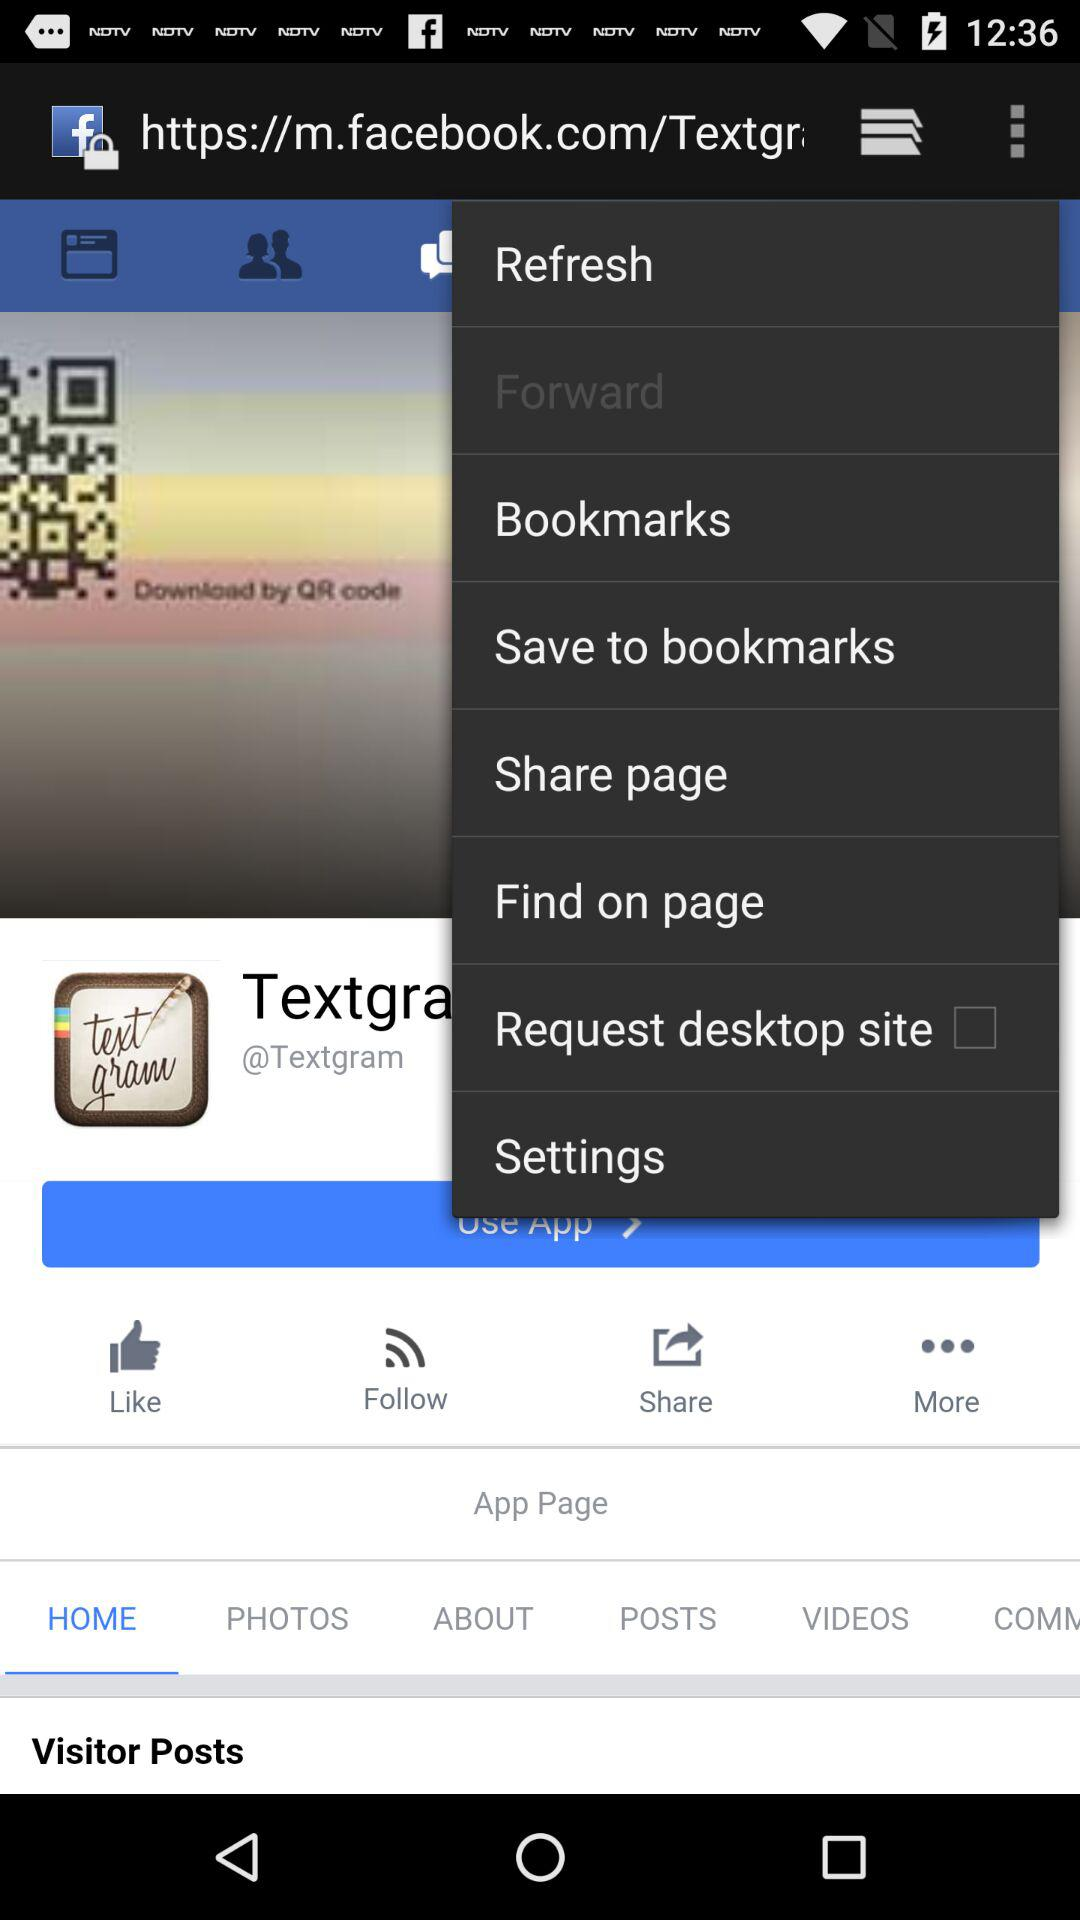Is the "Request desktop site" checked or not? The "Request desktop site" is unchecked. 